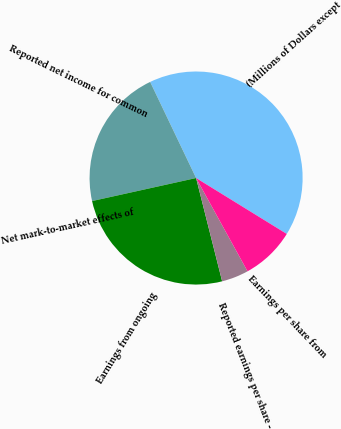Convert chart. <chart><loc_0><loc_0><loc_500><loc_500><pie_chart><fcel>(Millions of Dollars except<fcel>Reported net income for common<fcel>Net mark-to-market effects of<fcel>Earnings from ongoing<fcel>Reported earnings per share -<fcel>Earnings per share from<nl><fcel>40.89%<fcel>21.37%<fcel>0.0%<fcel>25.46%<fcel>4.09%<fcel>8.18%<nl></chart> 